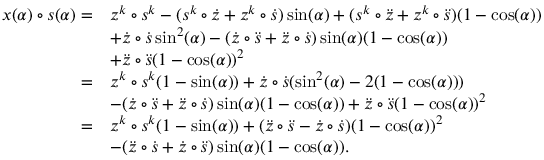Convert formula to latex. <formula><loc_0><loc_0><loc_500><loc_500>\begin{array} { r l } { x ( \alpha ) \circ s ( \alpha ) = } & { z ^ { k } \circ s ^ { k } - ( s ^ { k } \circ \dot { z } + z ^ { k } \circ \dot { s } ) \sin ( \alpha ) + ( s ^ { k } \circ \ddot { z } + z ^ { k } \circ \ddot { s } ) ( 1 - \cos ( \alpha ) ) } \\ & { + \dot { z } \circ \dot { s } \sin ^ { 2 } ( \alpha ) - ( \dot { z } \circ \ddot { s } + \ddot { z } \circ \dot { s } ) \sin ( \alpha ) ( 1 - \cos ( \alpha ) ) } \\ & { + \ddot { z } \circ \ddot { s } ( 1 - \cos ( \alpha ) ) ^ { 2 } } \\ { = } & { z ^ { k } \circ s ^ { k } ( 1 - \sin ( \alpha ) ) + \dot { z } \circ \dot { s } ( \sin ^ { 2 } ( \alpha ) - 2 ( 1 - \cos ( \alpha ) ) ) } \\ & { - ( \dot { z } \circ \ddot { s } + \ddot { z } \circ \dot { s } ) \sin ( \alpha ) ( 1 - \cos ( \alpha ) ) + \ddot { z } \circ \ddot { s } ( 1 - \cos ( \alpha ) ) ^ { 2 } } \\ { = } & { z ^ { k } \circ s ^ { k } ( 1 - \sin ( \alpha ) ) + ( \ddot { z } \circ \ddot { s } - \dot { z } \circ \dot { s } ) ( 1 - \cos ( \alpha ) ) ^ { 2 } } \\ & { - ( \ddot { z } \circ \dot { s } + \dot { z } \circ \ddot { s } ) \sin ( \alpha ) ( 1 - \cos ( \alpha ) ) . } \end{array}</formula> 